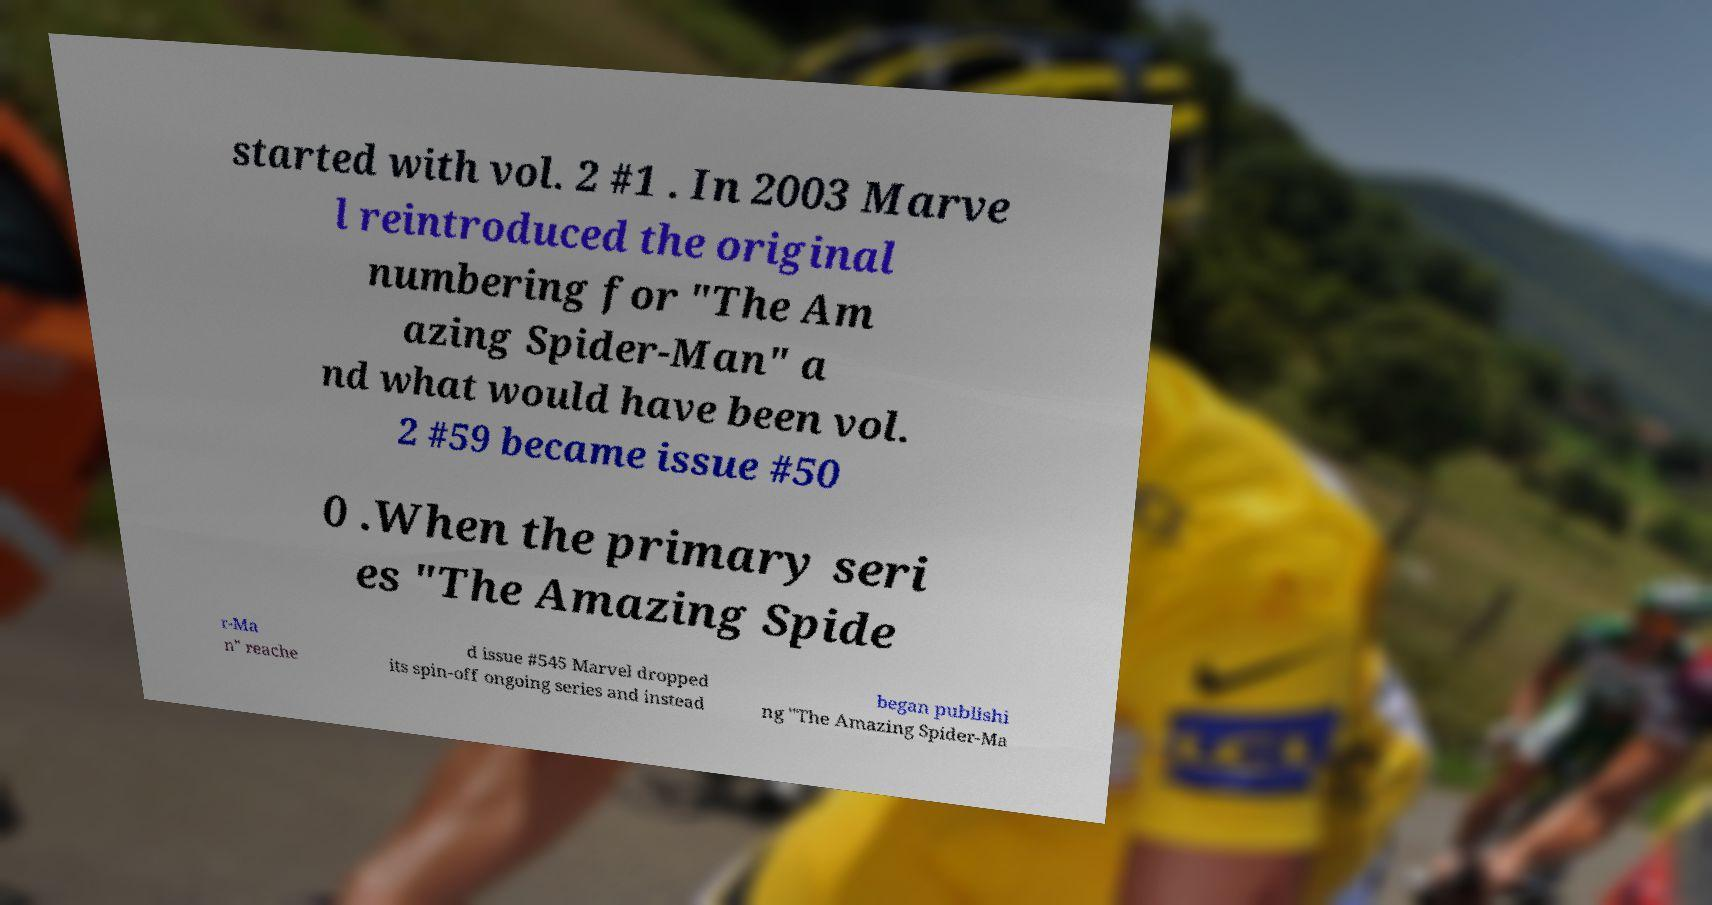Could you assist in decoding the text presented in this image and type it out clearly? started with vol. 2 #1 . In 2003 Marve l reintroduced the original numbering for "The Am azing Spider-Man" a nd what would have been vol. 2 #59 became issue #50 0 .When the primary seri es "The Amazing Spide r-Ma n" reache d issue #545 Marvel dropped its spin-off ongoing series and instead began publishi ng "The Amazing Spider-Ma 